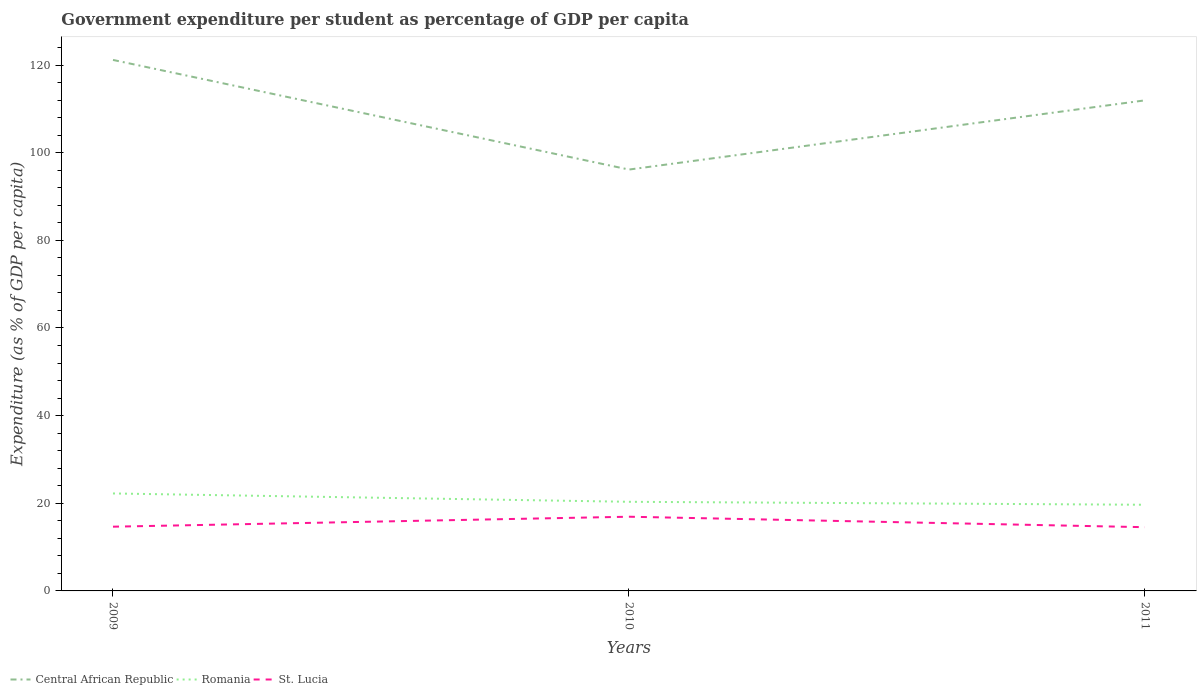Across all years, what is the maximum percentage of expenditure per student in St. Lucia?
Your response must be concise. 14.54. What is the total percentage of expenditure per student in Romania in the graph?
Provide a short and direct response. 2.58. What is the difference between the highest and the second highest percentage of expenditure per student in St. Lucia?
Give a very brief answer. 2.39. Are the values on the major ticks of Y-axis written in scientific E-notation?
Your response must be concise. No. How many legend labels are there?
Your answer should be compact. 3. How are the legend labels stacked?
Your answer should be compact. Horizontal. What is the title of the graph?
Make the answer very short. Government expenditure per student as percentage of GDP per capita. Does "Senegal" appear as one of the legend labels in the graph?
Offer a very short reply. No. What is the label or title of the X-axis?
Your response must be concise. Years. What is the label or title of the Y-axis?
Your response must be concise. Expenditure (as % of GDP per capita). What is the Expenditure (as % of GDP per capita) in Central African Republic in 2009?
Give a very brief answer. 121.16. What is the Expenditure (as % of GDP per capita) in Romania in 2009?
Give a very brief answer. 22.24. What is the Expenditure (as % of GDP per capita) in St. Lucia in 2009?
Your answer should be very brief. 14.66. What is the Expenditure (as % of GDP per capita) in Central African Republic in 2010?
Your answer should be very brief. 96.14. What is the Expenditure (as % of GDP per capita) in Romania in 2010?
Make the answer very short. 20.34. What is the Expenditure (as % of GDP per capita) of St. Lucia in 2010?
Your answer should be very brief. 16.93. What is the Expenditure (as % of GDP per capita) of Central African Republic in 2011?
Offer a terse response. 111.93. What is the Expenditure (as % of GDP per capita) of Romania in 2011?
Your answer should be compact. 19.66. What is the Expenditure (as % of GDP per capita) of St. Lucia in 2011?
Provide a short and direct response. 14.54. Across all years, what is the maximum Expenditure (as % of GDP per capita) in Central African Republic?
Keep it short and to the point. 121.16. Across all years, what is the maximum Expenditure (as % of GDP per capita) in Romania?
Keep it short and to the point. 22.24. Across all years, what is the maximum Expenditure (as % of GDP per capita) in St. Lucia?
Make the answer very short. 16.93. Across all years, what is the minimum Expenditure (as % of GDP per capita) of Central African Republic?
Make the answer very short. 96.14. Across all years, what is the minimum Expenditure (as % of GDP per capita) of Romania?
Your answer should be very brief. 19.66. Across all years, what is the minimum Expenditure (as % of GDP per capita) of St. Lucia?
Keep it short and to the point. 14.54. What is the total Expenditure (as % of GDP per capita) of Central African Republic in the graph?
Give a very brief answer. 329.23. What is the total Expenditure (as % of GDP per capita) of Romania in the graph?
Your response must be concise. 62.24. What is the total Expenditure (as % of GDP per capita) in St. Lucia in the graph?
Your response must be concise. 46.13. What is the difference between the Expenditure (as % of GDP per capita) of Central African Republic in 2009 and that in 2010?
Offer a very short reply. 25.01. What is the difference between the Expenditure (as % of GDP per capita) in Romania in 2009 and that in 2010?
Provide a succinct answer. 1.9. What is the difference between the Expenditure (as % of GDP per capita) of St. Lucia in 2009 and that in 2010?
Your answer should be very brief. -2.27. What is the difference between the Expenditure (as % of GDP per capita) in Central African Republic in 2009 and that in 2011?
Ensure brevity in your answer.  9.22. What is the difference between the Expenditure (as % of GDP per capita) of Romania in 2009 and that in 2011?
Keep it short and to the point. 2.58. What is the difference between the Expenditure (as % of GDP per capita) of St. Lucia in 2009 and that in 2011?
Provide a short and direct response. 0.12. What is the difference between the Expenditure (as % of GDP per capita) in Central African Republic in 2010 and that in 2011?
Keep it short and to the point. -15.79. What is the difference between the Expenditure (as % of GDP per capita) in Romania in 2010 and that in 2011?
Your answer should be very brief. 0.68. What is the difference between the Expenditure (as % of GDP per capita) of St. Lucia in 2010 and that in 2011?
Make the answer very short. 2.39. What is the difference between the Expenditure (as % of GDP per capita) of Central African Republic in 2009 and the Expenditure (as % of GDP per capita) of Romania in 2010?
Give a very brief answer. 100.82. What is the difference between the Expenditure (as % of GDP per capita) in Central African Republic in 2009 and the Expenditure (as % of GDP per capita) in St. Lucia in 2010?
Your response must be concise. 104.23. What is the difference between the Expenditure (as % of GDP per capita) of Romania in 2009 and the Expenditure (as % of GDP per capita) of St. Lucia in 2010?
Provide a short and direct response. 5.31. What is the difference between the Expenditure (as % of GDP per capita) in Central African Republic in 2009 and the Expenditure (as % of GDP per capita) in Romania in 2011?
Make the answer very short. 101.5. What is the difference between the Expenditure (as % of GDP per capita) of Central African Republic in 2009 and the Expenditure (as % of GDP per capita) of St. Lucia in 2011?
Your answer should be very brief. 106.62. What is the difference between the Expenditure (as % of GDP per capita) of Romania in 2009 and the Expenditure (as % of GDP per capita) of St. Lucia in 2011?
Your answer should be very brief. 7.7. What is the difference between the Expenditure (as % of GDP per capita) in Central African Republic in 2010 and the Expenditure (as % of GDP per capita) in Romania in 2011?
Your answer should be compact. 76.48. What is the difference between the Expenditure (as % of GDP per capita) in Central African Republic in 2010 and the Expenditure (as % of GDP per capita) in St. Lucia in 2011?
Give a very brief answer. 81.6. What is the difference between the Expenditure (as % of GDP per capita) in Romania in 2010 and the Expenditure (as % of GDP per capita) in St. Lucia in 2011?
Offer a terse response. 5.8. What is the average Expenditure (as % of GDP per capita) of Central African Republic per year?
Provide a succinct answer. 109.74. What is the average Expenditure (as % of GDP per capita) of Romania per year?
Keep it short and to the point. 20.75. What is the average Expenditure (as % of GDP per capita) in St. Lucia per year?
Offer a very short reply. 15.38. In the year 2009, what is the difference between the Expenditure (as % of GDP per capita) in Central African Republic and Expenditure (as % of GDP per capita) in Romania?
Offer a very short reply. 98.92. In the year 2009, what is the difference between the Expenditure (as % of GDP per capita) in Central African Republic and Expenditure (as % of GDP per capita) in St. Lucia?
Make the answer very short. 106.5. In the year 2009, what is the difference between the Expenditure (as % of GDP per capita) of Romania and Expenditure (as % of GDP per capita) of St. Lucia?
Your response must be concise. 7.58. In the year 2010, what is the difference between the Expenditure (as % of GDP per capita) of Central African Republic and Expenditure (as % of GDP per capita) of Romania?
Your response must be concise. 75.81. In the year 2010, what is the difference between the Expenditure (as % of GDP per capita) of Central African Republic and Expenditure (as % of GDP per capita) of St. Lucia?
Provide a short and direct response. 79.21. In the year 2010, what is the difference between the Expenditure (as % of GDP per capita) of Romania and Expenditure (as % of GDP per capita) of St. Lucia?
Give a very brief answer. 3.41. In the year 2011, what is the difference between the Expenditure (as % of GDP per capita) of Central African Republic and Expenditure (as % of GDP per capita) of Romania?
Your response must be concise. 92.27. In the year 2011, what is the difference between the Expenditure (as % of GDP per capita) in Central African Republic and Expenditure (as % of GDP per capita) in St. Lucia?
Keep it short and to the point. 97.39. In the year 2011, what is the difference between the Expenditure (as % of GDP per capita) in Romania and Expenditure (as % of GDP per capita) in St. Lucia?
Offer a very short reply. 5.12. What is the ratio of the Expenditure (as % of GDP per capita) of Central African Republic in 2009 to that in 2010?
Your answer should be very brief. 1.26. What is the ratio of the Expenditure (as % of GDP per capita) in Romania in 2009 to that in 2010?
Give a very brief answer. 1.09. What is the ratio of the Expenditure (as % of GDP per capita) in St. Lucia in 2009 to that in 2010?
Offer a terse response. 0.87. What is the ratio of the Expenditure (as % of GDP per capita) of Central African Republic in 2009 to that in 2011?
Your response must be concise. 1.08. What is the ratio of the Expenditure (as % of GDP per capita) of Romania in 2009 to that in 2011?
Ensure brevity in your answer.  1.13. What is the ratio of the Expenditure (as % of GDP per capita) in Central African Republic in 2010 to that in 2011?
Keep it short and to the point. 0.86. What is the ratio of the Expenditure (as % of GDP per capita) of Romania in 2010 to that in 2011?
Offer a very short reply. 1.03. What is the ratio of the Expenditure (as % of GDP per capita) in St. Lucia in 2010 to that in 2011?
Offer a terse response. 1.16. What is the difference between the highest and the second highest Expenditure (as % of GDP per capita) in Central African Republic?
Your response must be concise. 9.22. What is the difference between the highest and the second highest Expenditure (as % of GDP per capita) in Romania?
Ensure brevity in your answer.  1.9. What is the difference between the highest and the second highest Expenditure (as % of GDP per capita) of St. Lucia?
Provide a succinct answer. 2.27. What is the difference between the highest and the lowest Expenditure (as % of GDP per capita) in Central African Republic?
Your answer should be compact. 25.01. What is the difference between the highest and the lowest Expenditure (as % of GDP per capita) of Romania?
Offer a terse response. 2.58. What is the difference between the highest and the lowest Expenditure (as % of GDP per capita) in St. Lucia?
Provide a short and direct response. 2.39. 